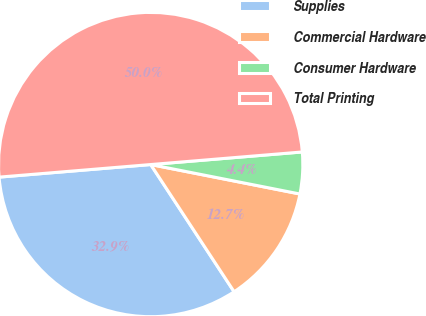<chart> <loc_0><loc_0><loc_500><loc_500><pie_chart><fcel>Supplies<fcel>Commercial Hardware<fcel>Consumer Hardware<fcel>Total Printing<nl><fcel>32.92%<fcel>12.66%<fcel>4.42%<fcel>50.0%<nl></chart> 